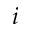<formula> <loc_0><loc_0><loc_500><loc_500>i</formula> 